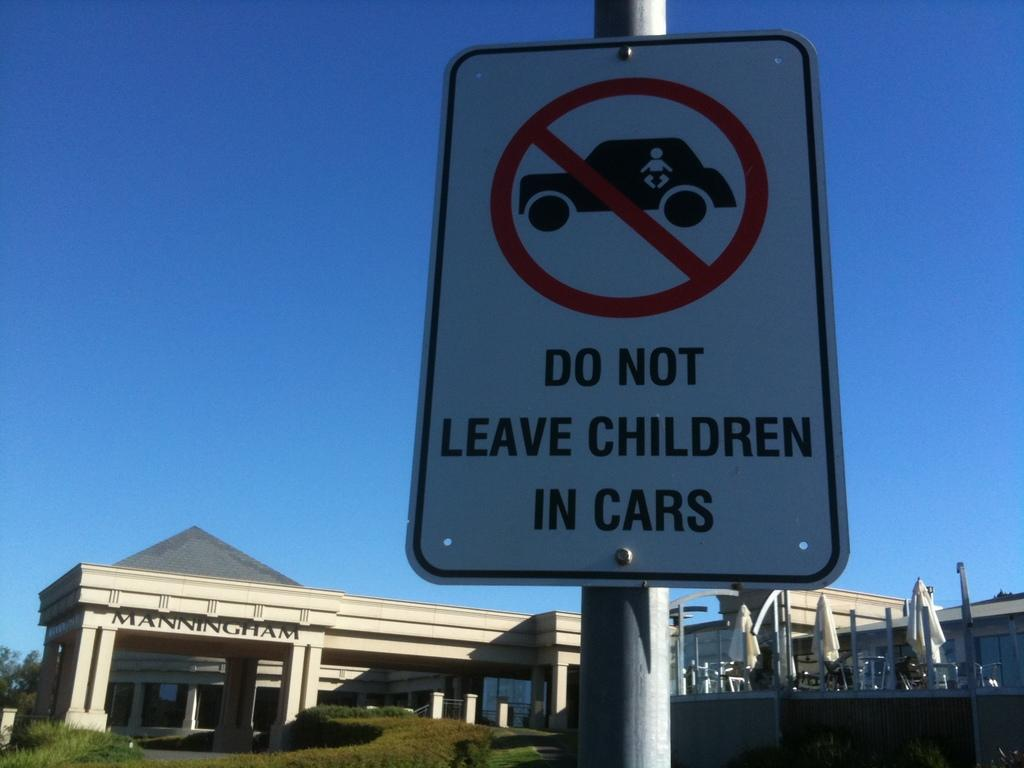<image>
Share a concise interpretation of the image provided. A sign that warns people not to leave children in cars. 